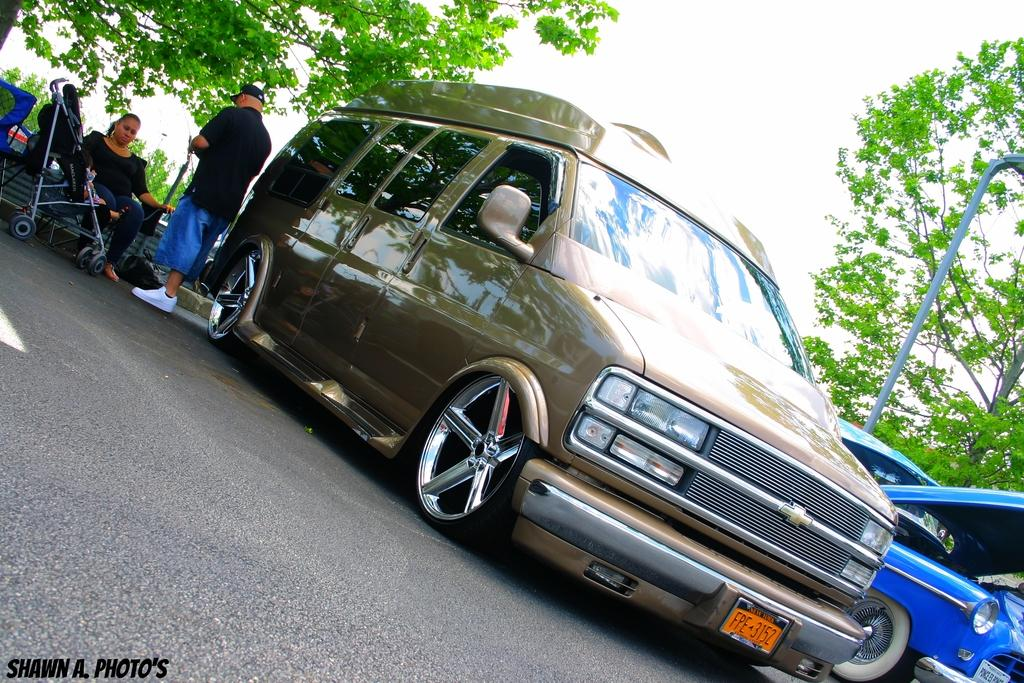What is the main subject of the image? The main subject of the image is a car on the road. Can you describe the people in the image? A woman is sitting on the left side of the car, and a man is standing near the car. What can be seen in the background of the image? There are trees visible in the image. What type of van can be seen bursting into flames in the image? There is no van present in the image, nor is there any indication of a fire or explosion. 